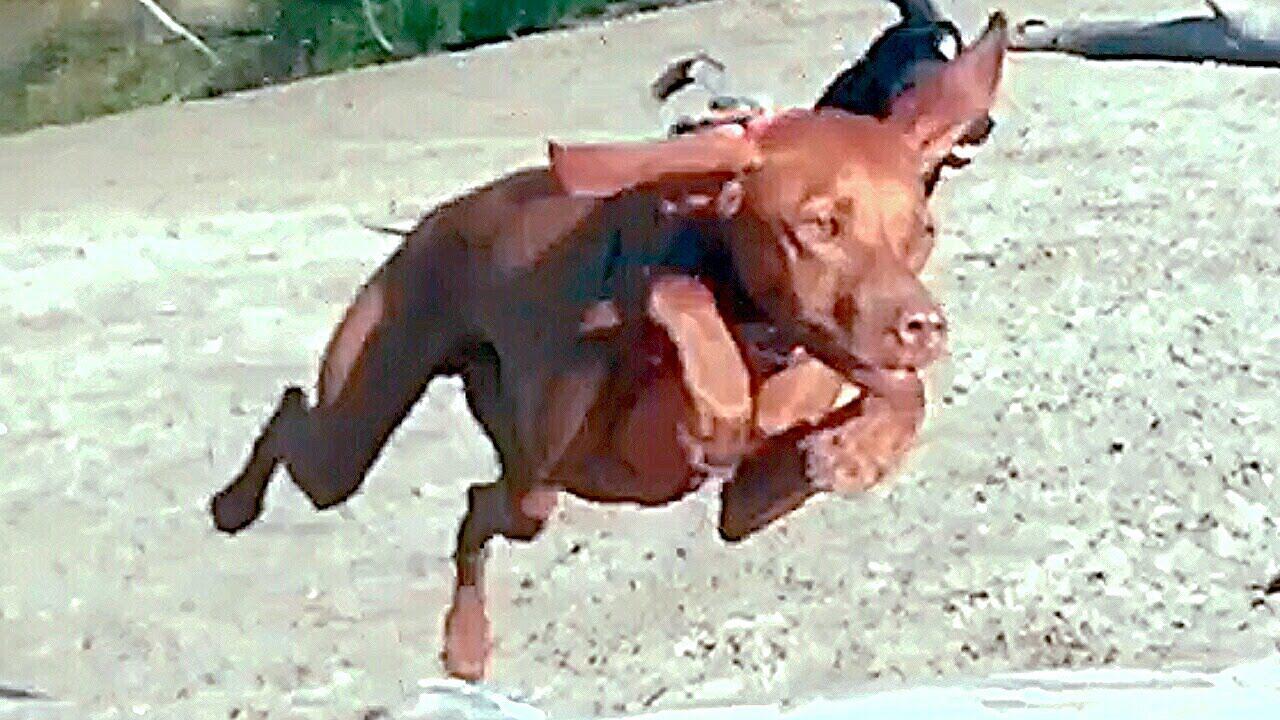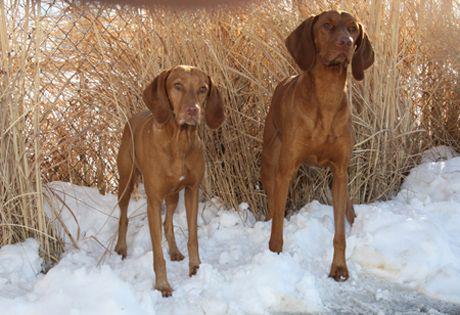The first image is the image on the left, the second image is the image on the right. Given the left and right images, does the statement "The combined images contain no more than three dogs, and at least two dogs are standing on all fours." hold true? Answer yes or no. Yes. 